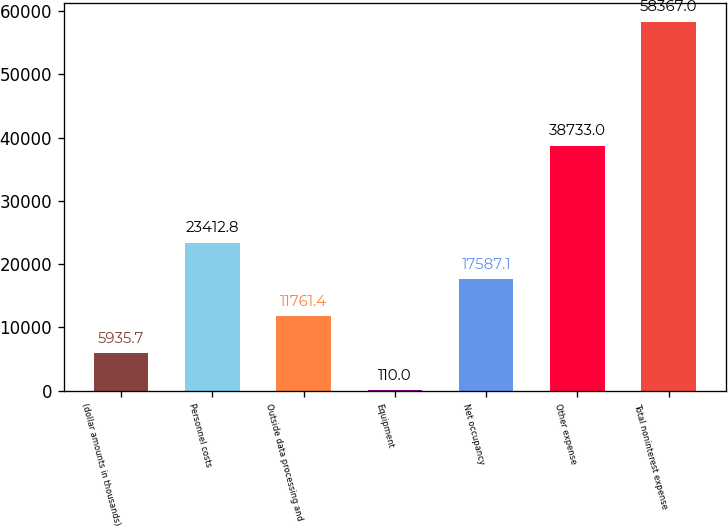Convert chart to OTSL. <chart><loc_0><loc_0><loc_500><loc_500><bar_chart><fcel>(dollar amounts in thousands)<fcel>Personnel costs<fcel>Outside data processing and<fcel>Equipment<fcel>Net occupancy<fcel>Other expense<fcel>Total noninterest expense<nl><fcel>5935.7<fcel>23412.8<fcel>11761.4<fcel>110<fcel>17587.1<fcel>38733<fcel>58367<nl></chart> 